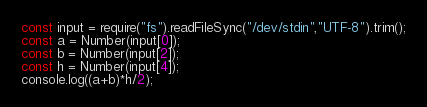Convert code to text. <code><loc_0><loc_0><loc_500><loc_500><_JavaScript_>const input = require("fs").readFileSync("/dev/stdin","UTF-8").trim();
const a = Number(input[0]);
const b = Number(input[2]);
const h = Number(input[4]);
console.log((a+b)*h/2);</code> 